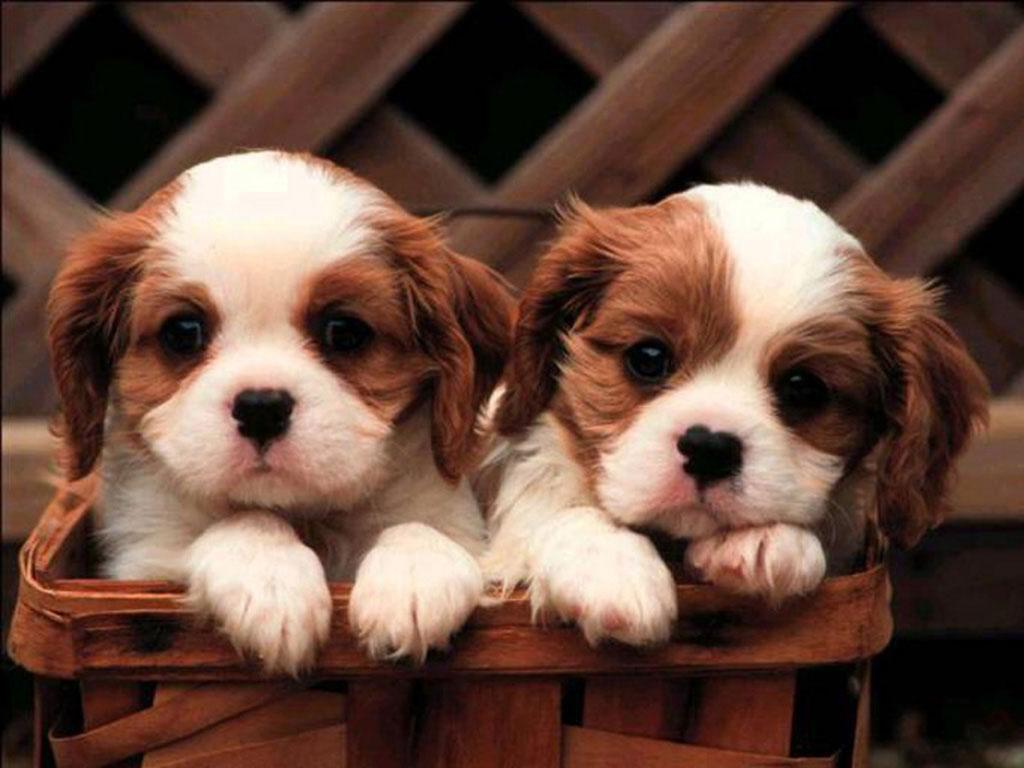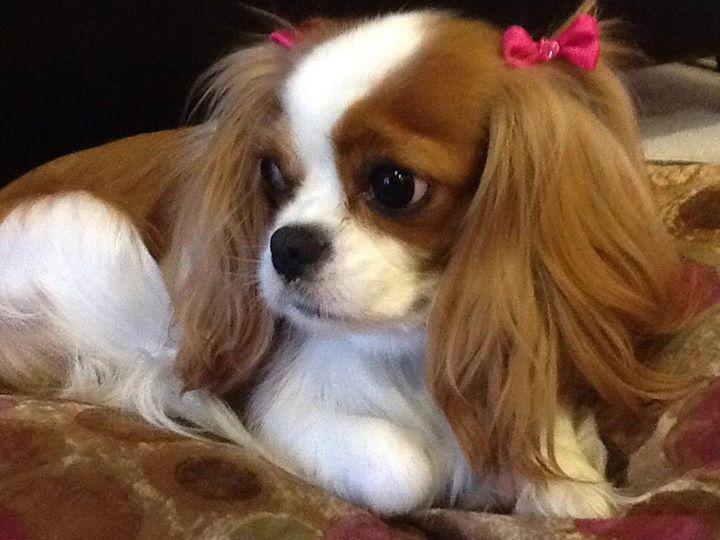The first image is the image on the left, the second image is the image on the right. Assess this claim about the two images: "There is a dog resting in the grass". Correct or not? Answer yes or no. No. 